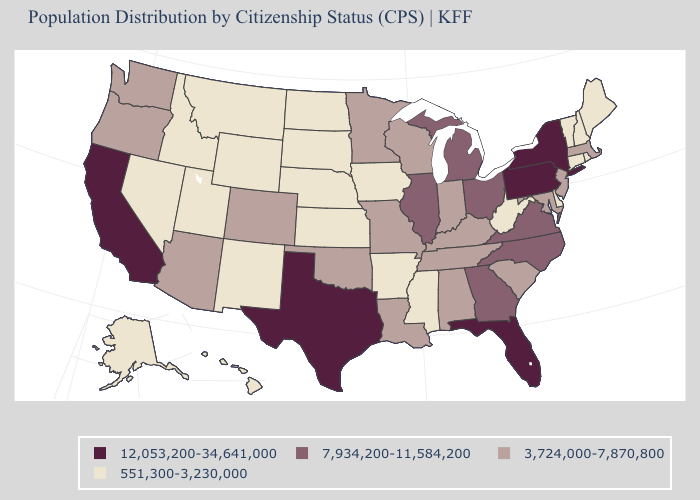Name the states that have a value in the range 551,300-3,230,000?
Quick response, please. Alaska, Arkansas, Connecticut, Delaware, Hawaii, Idaho, Iowa, Kansas, Maine, Mississippi, Montana, Nebraska, Nevada, New Hampshire, New Mexico, North Dakota, Rhode Island, South Dakota, Utah, Vermont, West Virginia, Wyoming. Name the states that have a value in the range 3,724,000-7,870,800?
Short answer required. Alabama, Arizona, Colorado, Indiana, Kentucky, Louisiana, Maryland, Massachusetts, Minnesota, Missouri, New Jersey, Oklahoma, Oregon, South Carolina, Tennessee, Washington, Wisconsin. Among the states that border Delaware , does New Jersey have the lowest value?
Give a very brief answer. Yes. Is the legend a continuous bar?
Concise answer only. No. Does Wyoming have the lowest value in the USA?
Short answer required. Yes. Name the states that have a value in the range 7,934,200-11,584,200?
Give a very brief answer. Georgia, Illinois, Michigan, North Carolina, Ohio, Virginia. Among the states that border Texas , does New Mexico have the highest value?
Short answer required. No. Does Missouri have a lower value than Pennsylvania?
Be succinct. Yes. Which states hav the highest value in the West?
Quick response, please. California. Does North Dakota have a higher value than New Hampshire?
Give a very brief answer. No. What is the highest value in the MidWest ?
Quick response, please. 7,934,200-11,584,200. Name the states that have a value in the range 3,724,000-7,870,800?
Keep it brief. Alabama, Arizona, Colorado, Indiana, Kentucky, Louisiana, Maryland, Massachusetts, Minnesota, Missouri, New Jersey, Oklahoma, Oregon, South Carolina, Tennessee, Washington, Wisconsin. What is the value of Delaware?
Short answer required. 551,300-3,230,000. Name the states that have a value in the range 7,934,200-11,584,200?
Keep it brief. Georgia, Illinois, Michigan, North Carolina, Ohio, Virginia. Name the states that have a value in the range 7,934,200-11,584,200?
Quick response, please. Georgia, Illinois, Michigan, North Carolina, Ohio, Virginia. 